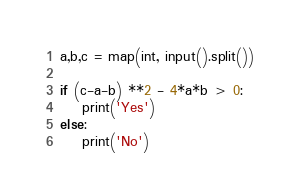Convert code to text. <code><loc_0><loc_0><loc_500><loc_500><_Python_>a,b,c = map(int, input().split())

if (c-a-b) **2 - 4*a*b > 0:
    print('Yes')
else:
    print('No')
</code> 